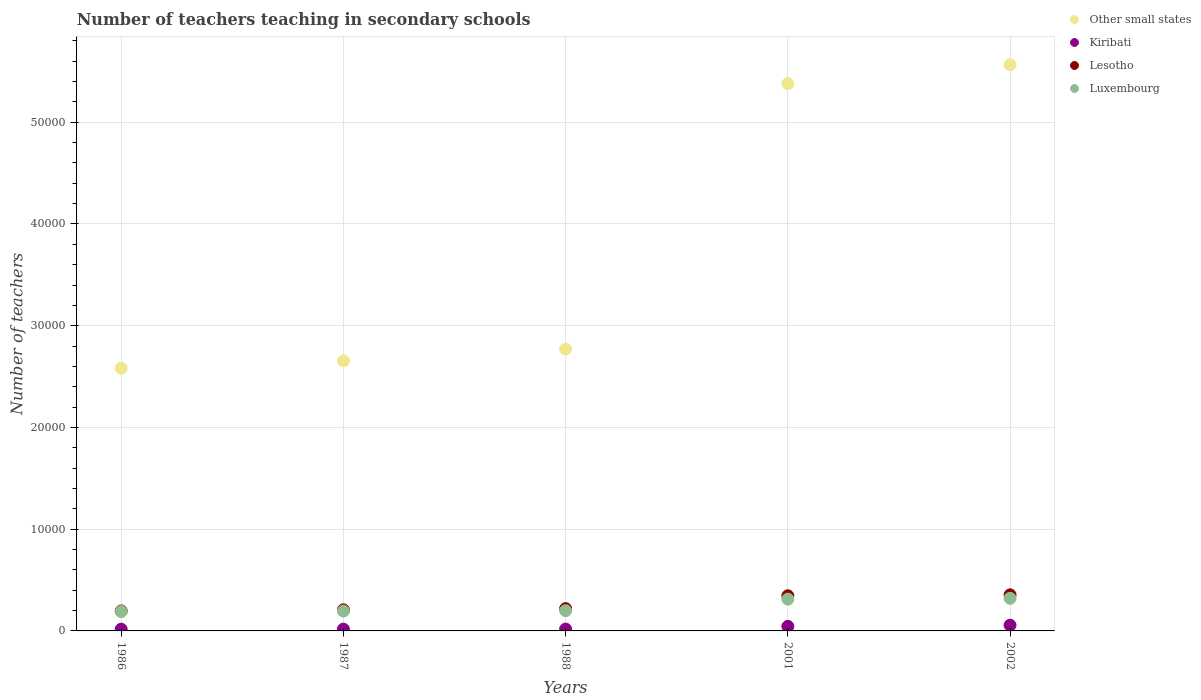How many different coloured dotlines are there?
Offer a very short reply. 4. Is the number of dotlines equal to the number of legend labels?
Offer a very short reply. Yes. What is the number of teachers teaching in secondary schools in Luxembourg in 2002?
Keep it short and to the point. 3206. Across all years, what is the maximum number of teachers teaching in secondary schools in Other small states?
Your answer should be very brief. 5.56e+04. Across all years, what is the minimum number of teachers teaching in secondary schools in Other small states?
Provide a succinct answer. 2.58e+04. In which year was the number of teachers teaching in secondary schools in Kiribati maximum?
Your response must be concise. 2002. In which year was the number of teachers teaching in secondary schools in Luxembourg minimum?
Your answer should be very brief. 1986. What is the total number of teachers teaching in secondary schools in Other small states in the graph?
Provide a short and direct response. 1.90e+05. What is the difference between the number of teachers teaching in secondary schools in Other small states in 1986 and that in 1987?
Your answer should be compact. -724.04. What is the difference between the number of teachers teaching in secondary schools in Other small states in 2002 and the number of teachers teaching in secondary schools in Lesotho in 1987?
Give a very brief answer. 5.36e+04. What is the average number of teachers teaching in secondary schools in Other small states per year?
Make the answer very short. 3.79e+04. In the year 1988, what is the difference between the number of teachers teaching in secondary schools in Lesotho and number of teachers teaching in secondary schools in Kiribati?
Keep it short and to the point. 2011. In how many years, is the number of teachers teaching in secondary schools in Kiribati greater than 50000?
Ensure brevity in your answer.  0. What is the ratio of the number of teachers teaching in secondary schools in Other small states in 1987 to that in 1988?
Your answer should be very brief. 0.96. Is the number of teachers teaching in secondary schools in Kiribati in 1986 less than that in 1987?
Keep it short and to the point. Yes. What is the difference between the highest and the second highest number of teachers teaching in secondary schools in Luxembourg?
Provide a short and direct response. 81. What is the difference between the highest and the lowest number of teachers teaching in secondary schools in Kiribati?
Offer a very short reply. 391. Is the sum of the number of teachers teaching in secondary schools in Kiribati in 1988 and 2002 greater than the maximum number of teachers teaching in secondary schools in Other small states across all years?
Your answer should be compact. No. Is it the case that in every year, the sum of the number of teachers teaching in secondary schools in Other small states and number of teachers teaching in secondary schools in Luxembourg  is greater than the number of teachers teaching in secondary schools in Lesotho?
Offer a terse response. Yes. Is the number of teachers teaching in secondary schools in Lesotho strictly less than the number of teachers teaching in secondary schools in Other small states over the years?
Give a very brief answer. Yes. Does the graph contain any zero values?
Your answer should be very brief. No. Does the graph contain grids?
Your answer should be compact. Yes. How are the legend labels stacked?
Give a very brief answer. Vertical. What is the title of the graph?
Your answer should be very brief. Number of teachers teaching in secondary schools. What is the label or title of the Y-axis?
Keep it short and to the point. Number of teachers. What is the Number of teachers of Other small states in 1986?
Provide a short and direct response. 2.58e+04. What is the Number of teachers in Kiribati in 1986?
Offer a very short reply. 171. What is the Number of teachers in Lesotho in 1986?
Your answer should be very brief. 1961. What is the Number of teachers of Luxembourg in 1986?
Provide a short and direct response. 1908. What is the Number of teachers in Other small states in 1987?
Ensure brevity in your answer.  2.65e+04. What is the Number of teachers of Kiribati in 1987?
Offer a terse response. 174. What is the Number of teachers of Lesotho in 1987?
Your answer should be compact. 2074. What is the Number of teachers of Luxembourg in 1987?
Your response must be concise. 1955. What is the Number of teachers in Other small states in 1988?
Provide a succinct answer. 2.77e+04. What is the Number of teachers of Kiribati in 1988?
Your response must be concise. 182. What is the Number of teachers in Lesotho in 1988?
Ensure brevity in your answer.  2193. What is the Number of teachers in Luxembourg in 1988?
Your answer should be very brief. 1990. What is the Number of teachers in Other small states in 2001?
Give a very brief answer. 5.38e+04. What is the Number of teachers of Kiribati in 2001?
Ensure brevity in your answer.  449. What is the Number of teachers of Lesotho in 2001?
Ensure brevity in your answer.  3455. What is the Number of teachers in Luxembourg in 2001?
Your response must be concise. 3125. What is the Number of teachers in Other small states in 2002?
Make the answer very short. 5.56e+04. What is the Number of teachers in Kiribati in 2002?
Your response must be concise. 562. What is the Number of teachers in Lesotho in 2002?
Your response must be concise. 3546. What is the Number of teachers in Luxembourg in 2002?
Your answer should be very brief. 3206. Across all years, what is the maximum Number of teachers of Other small states?
Your response must be concise. 5.56e+04. Across all years, what is the maximum Number of teachers in Kiribati?
Your response must be concise. 562. Across all years, what is the maximum Number of teachers in Lesotho?
Offer a very short reply. 3546. Across all years, what is the maximum Number of teachers in Luxembourg?
Keep it short and to the point. 3206. Across all years, what is the minimum Number of teachers in Other small states?
Give a very brief answer. 2.58e+04. Across all years, what is the minimum Number of teachers of Kiribati?
Ensure brevity in your answer.  171. Across all years, what is the minimum Number of teachers in Lesotho?
Keep it short and to the point. 1961. Across all years, what is the minimum Number of teachers of Luxembourg?
Offer a terse response. 1908. What is the total Number of teachers in Other small states in the graph?
Provide a short and direct response. 1.90e+05. What is the total Number of teachers in Kiribati in the graph?
Your answer should be compact. 1538. What is the total Number of teachers in Lesotho in the graph?
Your answer should be very brief. 1.32e+04. What is the total Number of teachers of Luxembourg in the graph?
Your answer should be very brief. 1.22e+04. What is the difference between the Number of teachers of Other small states in 1986 and that in 1987?
Provide a succinct answer. -724.04. What is the difference between the Number of teachers of Kiribati in 1986 and that in 1987?
Offer a very short reply. -3. What is the difference between the Number of teachers in Lesotho in 1986 and that in 1987?
Provide a succinct answer. -113. What is the difference between the Number of teachers in Luxembourg in 1986 and that in 1987?
Your answer should be compact. -47. What is the difference between the Number of teachers in Other small states in 1986 and that in 1988?
Ensure brevity in your answer.  -1891.17. What is the difference between the Number of teachers of Lesotho in 1986 and that in 1988?
Offer a terse response. -232. What is the difference between the Number of teachers of Luxembourg in 1986 and that in 1988?
Offer a very short reply. -82. What is the difference between the Number of teachers in Other small states in 1986 and that in 2001?
Offer a terse response. -2.80e+04. What is the difference between the Number of teachers in Kiribati in 1986 and that in 2001?
Keep it short and to the point. -278. What is the difference between the Number of teachers in Lesotho in 1986 and that in 2001?
Your response must be concise. -1494. What is the difference between the Number of teachers in Luxembourg in 1986 and that in 2001?
Offer a very short reply. -1217. What is the difference between the Number of teachers in Other small states in 1986 and that in 2002?
Give a very brief answer. -2.98e+04. What is the difference between the Number of teachers in Kiribati in 1986 and that in 2002?
Your answer should be compact. -391. What is the difference between the Number of teachers of Lesotho in 1986 and that in 2002?
Give a very brief answer. -1585. What is the difference between the Number of teachers of Luxembourg in 1986 and that in 2002?
Your answer should be very brief. -1298. What is the difference between the Number of teachers of Other small states in 1987 and that in 1988?
Provide a short and direct response. -1167.13. What is the difference between the Number of teachers in Lesotho in 1987 and that in 1988?
Offer a very short reply. -119. What is the difference between the Number of teachers in Luxembourg in 1987 and that in 1988?
Give a very brief answer. -35. What is the difference between the Number of teachers in Other small states in 1987 and that in 2001?
Offer a very short reply. -2.73e+04. What is the difference between the Number of teachers in Kiribati in 1987 and that in 2001?
Provide a succinct answer. -275. What is the difference between the Number of teachers in Lesotho in 1987 and that in 2001?
Make the answer very short. -1381. What is the difference between the Number of teachers of Luxembourg in 1987 and that in 2001?
Ensure brevity in your answer.  -1170. What is the difference between the Number of teachers in Other small states in 1987 and that in 2002?
Keep it short and to the point. -2.91e+04. What is the difference between the Number of teachers in Kiribati in 1987 and that in 2002?
Keep it short and to the point. -388. What is the difference between the Number of teachers of Lesotho in 1987 and that in 2002?
Make the answer very short. -1472. What is the difference between the Number of teachers in Luxembourg in 1987 and that in 2002?
Your response must be concise. -1251. What is the difference between the Number of teachers of Other small states in 1988 and that in 2001?
Your answer should be very brief. -2.61e+04. What is the difference between the Number of teachers of Kiribati in 1988 and that in 2001?
Your response must be concise. -267. What is the difference between the Number of teachers of Lesotho in 1988 and that in 2001?
Your answer should be compact. -1262. What is the difference between the Number of teachers in Luxembourg in 1988 and that in 2001?
Offer a terse response. -1135. What is the difference between the Number of teachers in Other small states in 1988 and that in 2002?
Give a very brief answer. -2.79e+04. What is the difference between the Number of teachers of Kiribati in 1988 and that in 2002?
Ensure brevity in your answer.  -380. What is the difference between the Number of teachers in Lesotho in 1988 and that in 2002?
Keep it short and to the point. -1353. What is the difference between the Number of teachers in Luxembourg in 1988 and that in 2002?
Your answer should be very brief. -1216. What is the difference between the Number of teachers in Other small states in 2001 and that in 2002?
Your answer should be compact. -1847.14. What is the difference between the Number of teachers of Kiribati in 2001 and that in 2002?
Provide a short and direct response. -113. What is the difference between the Number of teachers in Lesotho in 2001 and that in 2002?
Offer a terse response. -91. What is the difference between the Number of teachers of Luxembourg in 2001 and that in 2002?
Your answer should be very brief. -81. What is the difference between the Number of teachers in Other small states in 1986 and the Number of teachers in Kiribati in 1987?
Ensure brevity in your answer.  2.56e+04. What is the difference between the Number of teachers in Other small states in 1986 and the Number of teachers in Lesotho in 1987?
Provide a short and direct response. 2.37e+04. What is the difference between the Number of teachers of Other small states in 1986 and the Number of teachers of Luxembourg in 1987?
Ensure brevity in your answer.  2.39e+04. What is the difference between the Number of teachers of Kiribati in 1986 and the Number of teachers of Lesotho in 1987?
Make the answer very short. -1903. What is the difference between the Number of teachers of Kiribati in 1986 and the Number of teachers of Luxembourg in 1987?
Give a very brief answer. -1784. What is the difference between the Number of teachers in Other small states in 1986 and the Number of teachers in Kiribati in 1988?
Your answer should be compact. 2.56e+04. What is the difference between the Number of teachers of Other small states in 1986 and the Number of teachers of Lesotho in 1988?
Offer a terse response. 2.36e+04. What is the difference between the Number of teachers of Other small states in 1986 and the Number of teachers of Luxembourg in 1988?
Offer a terse response. 2.38e+04. What is the difference between the Number of teachers of Kiribati in 1986 and the Number of teachers of Lesotho in 1988?
Offer a very short reply. -2022. What is the difference between the Number of teachers in Kiribati in 1986 and the Number of teachers in Luxembourg in 1988?
Make the answer very short. -1819. What is the difference between the Number of teachers in Other small states in 1986 and the Number of teachers in Kiribati in 2001?
Offer a very short reply. 2.54e+04. What is the difference between the Number of teachers in Other small states in 1986 and the Number of teachers in Lesotho in 2001?
Keep it short and to the point. 2.24e+04. What is the difference between the Number of teachers of Other small states in 1986 and the Number of teachers of Luxembourg in 2001?
Keep it short and to the point. 2.27e+04. What is the difference between the Number of teachers in Kiribati in 1986 and the Number of teachers in Lesotho in 2001?
Your response must be concise. -3284. What is the difference between the Number of teachers of Kiribati in 1986 and the Number of teachers of Luxembourg in 2001?
Your answer should be very brief. -2954. What is the difference between the Number of teachers in Lesotho in 1986 and the Number of teachers in Luxembourg in 2001?
Provide a short and direct response. -1164. What is the difference between the Number of teachers in Other small states in 1986 and the Number of teachers in Kiribati in 2002?
Your answer should be compact. 2.53e+04. What is the difference between the Number of teachers of Other small states in 1986 and the Number of teachers of Lesotho in 2002?
Make the answer very short. 2.23e+04. What is the difference between the Number of teachers of Other small states in 1986 and the Number of teachers of Luxembourg in 2002?
Offer a terse response. 2.26e+04. What is the difference between the Number of teachers in Kiribati in 1986 and the Number of teachers in Lesotho in 2002?
Your answer should be very brief. -3375. What is the difference between the Number of teachers in Kiribati in 1986 and the Number of teachers in Luxembourg in 2002?
Offer a terse response. -3035. What is the difference between the Number of teachers of Lesotho in 1986 and the Number of teachers of Luxembourg in 2002?
Make the answer very short. -1245. What is the difference between the Number of teachers in Other small states in 1987 and the Number of teachers in Kiribati in 1988?
Offer a terse response. 2.64e+04. What is the difference between the Number of teachers in Other small states in 1987 and the Number of teachers in Lesotho in 1988?
Ensure brevity in your answer.  2.43e+04. What is the difference between the Number of teachers of Other small states in 1987 and the Number of teachers of Luxembourg in 1988?
Provide a short and direct response. 2.46e+04. What is the difference between the Number of teachers in Kiribati in 1987 and the Number of teachers in Lesotho in 1988?
Ensure brevity in your answer.  -2019. What is the difference between the Number of teachers of Kiribati in 1987 and the Number of teachers of Luxembourg in 1988?
Provide a short and direct response. -1816. What is the difference between the Number of teachers in Other small states in 1987 and the Number of teachers in Kiribati in 2001?
Your answer should be very brief. 2.61e+04. What is the difference between the Number of teachers in Other small states in 1987 and the Number of teachers in Lesotho in 2001?
Give a very brief answer. 2.31e+04. What is the difference between the Number of teachers in Other small states in 1987 and the Number of teachers in Luxembourg in 2001?
Your response must be concise. 2.34e+04. What is the difference between the Number of teachers in Kiribati in 1987 and the Number of teachers in Lesotho in 2001?
Offer a very short reply. -3281. What is the difference between the Number of teachers in Kiribati in 1987 and the Number of teachers in Luxembourg in 2001?
Ensure brevity in your answer.  -2951. What is the difference between the Number of teachers of Lesotho in 1987 and the Number of teachers of Luxembourg in 2001?
Your answer should be very brief. -1051. What is the difference between the Number of teachers of Other small states in 1987 and the Number of teachers of Kiribati in 2002?
Offer a terse response. 2.60e+04. What is the difference between the Number of teachers of Other small states in 1987 and the Number of teachers of Lesotho in 2002?
Keep it short and to the point. 2.30e+04. What is the difference between the Number of teachers in Other small states in 1987 and the Number of teachers in Luxembourg in 2002?
Provide a succinct answer. 2.33e+04. What is the difference between the Number of teachers of Kiribati in 1987 and the Number of teachers of Lesotho in 2002?
Give a very brief answer. -3372. What is the difference between the Number of teachers in Kiribati in 1987 and the Number of teachers in Luxembourg in 2002?
Provide a succinct answer. -3032. What is the difference between the Number of teachers of Lesotho in 1987 and the Number of teachers of Luxembourg in 2002?
Offer a very short reply. -1132. What is the difference between the Number of teachers in Other small states in 1988 and the Number of teachers in Kiribati in 2001?
Keep it short and to the point. 2.73e+04. What is the difference between the Number of teachers of Other small states in 1988 and the Number of teachers of Lesotho in 2001?
Provide a short and direct response. 2.43e+04. What is the difference between the Number of teachers of Other small states in 1988 and the Number of teachers of Luxembourg in 2001?
Keep it short and to the point. 2.46e+04. What is the difference between the Number of teachers of Kiribati in 1988 and the Number of teachers of Lesotho in 2001?
Ensure brevity in your answer.  -3273. What is the difference between the Number of teachers of Kiribati in 1988 and the Number of teachers of Luxembourg in 2001?
Give a very brief answer. -2943. What is the difference between the Number of teachers in Lesotho in 1988 and the Number of teachers in Luxembourg in 2001?
Your response must be concise. -932. What is the difference between the Number of teachers in Other small states in 1988 and the Number of teachers in Kiribati in 2002?
Give a very brief answer. 2.71e+04. What is the difference between the Number of teachers of Other small states in 1988 and the Number of teachers of Lesotho in 2002?
Offer a terse response. 2.42e+04. What is the difference between the Number of teachers in Other small states in 1988 and the Number of teachers in Luxembourg in 2002?
Keep it short and to the point. 2.45e+04. What is the difference between the Number of teachers in Kiribati in 1988 and the Number of teachers in Lesotho in 2002?
Keep it short and to the point. -3364. What is the difference between the Number of teachers of Kiribati in 1988 and the Number of teachers of Luxembourg in 2002?
Provide a short and direct response. -3024. What is the difference between the Number of teachers in Lesotho in 1988 and the Number of teachers in Luxembourg in 2002?
Keep it short and to the point. -1013. What is the difference between the Number of teachers of Other small states in 2001 and the Number of teachers of Kiribati in 2002?
Your answer should be very brief. 5.32e+04. What is the difference between the Number of teachers of Other small states in 2001 and the Number of teachers of Lesotho in 2002?
Make the answer very short. 5.03e+04. What is the difference between the Number of teachers in Other small states in 2001 and the Number of teachers in Luxembourg in 2002?
Give a very brief answer. 5.06e+04. What is the difference between the Number of teachers in Kiribati in 2001 and the Number of teachers in Lesotho in 2002?
Ensure brevity in your answer.  -3097. What is the difference between the Number of teachers in Kiribati in 2001 and the Number of teachers in Luxembourg in 2002?
Your answer should be very brief. -2757. What is the difference between the Number of teachers of Lesotho in 2001 and the Number of teachers of Luxembourg in 2002?
Your answer should be very brief. 249. What is the average Number of teachers in Other small states per year?
Provide a short and direct response. 3.79e+04. What is the average Number of teachers of Kiribati per year?
Your response must be concise. 307.6. What is the average Number of teachers of Lesotho per year?
Keep it short and to the point. 2645.8. What is the average Number of teachers of Luxembourg per year?
Your response must be concise. 2436.8. In the year 1986, what is the difference between the Number of teachers in Other small states and Number of teachers in Kiribati?
Provide a succinct answer. 2.56e+04. In the year 1986, what is the difference between the Number of teachers in Other small states and Number of teachers in Lesotho?
Offer a very short reply. 2.39e+04. In the year 1986, what is the difference between the Number of teachers of Other small states and Number of teachers of Luxembourg?
Offer a very short reply. 2.39e+04. In the year 1986, what is the difference between the Number of teachers of Kiribati and Number of teachers of Lesotho?
Give a very brief answer. -1790. In the year 1986, what is the difference between the Number of teachers in Kiribati and Number of teachers in Luxembourg?
Offer a terse response. -1737. In the year 1986, what is the difference between the Number of teachers of Lesotho and Number of teachers of Luxembourg?
Offer a terse response. 53. In the year 1987, what is the difference between the Number of teachers of Other small states and Number of teachers of Kiribati?
Make the answer very short. 2.64e+04. In the year 1987, what is the difference between the Number of teachers of Other small states and Number of teachers of Lesotho?
Provide a succinct answer. 2.45e+04. In the year 1987, what is the difference between the Number of teachers in Other small states and Number of teachers in Luxembourg?
Your answer should be compact. 2.46e+04. In the year 1987, what is the difference between the Number of teachers in Kiribati and Number of teachers in Lesotho?
Give a very brief answer. -1900. In the year 1987, what is the difference between the Number of teachers in Kiribati and Number of teachers in Luxembourg?
Offer a terse response. -1781. In the year 1987, what is the difference between the Number of teachers in Lesotho and Number of teachers in Luxembourg?
Offer a very short reply. 119. In the year 1988, what is the difference between the Number of teachers in Other small states and Number of teachers in Kiribati?
Your response must be concise. 2.75e+04. In the year 1988, what is the difference between the Number of teachers in Other small states and Number of teachers in Lesotho?
Give a very brief answer. 2.55e+04. In the year 1988, what is the difference between the Number of teachers in Other small states and Number of teachers in Luxembourg?
Your answer should be compact. 2.57e+04. In the year 1988, what is the difference between the Number of teachers in Kiribati and Number of teachers in Lesotho?
Offer a terse response. -2011. In the year 1988, what is the difference between the Number of teachers in Kiribati and Number of teachers in Luxembourg?
Your response must be concise. -1808. In the year 1988, what is the difference between the Number of teachers in Lesotho and Number of teachers in Luxembourg?
Provide a succinct answer. 203. In the year 2001, what is the difference between the Number of teachers of Other small states and Number of teachers of Kiribati?
Make the answer very short. 5.33e+04. In the year 2001, what is the difference between the Number of teachers in Other small states and Number of teachers in Lesotho?
Provide a short and direct response. 5.03e+04. In the year 2001, what is the difference between the Number of teachers of Other small states and Number of teachers of Luxembourg?
Your answer should be very brief. 5.07e+04. In the year 2001, what is the difference between the Number of teachers in Kiribati and Number of teachers in Lesotho?
Your answer should be compact. -3006. In the year 2001, what is the difference between the Number of teachers in Kiribati and Number of teachers in Luxembourg?
Provide a short and direct response. -2676. In the year 2001, what is the difference between the Number of teachers of Lesotho and Number of teachers of Luxembourg?
Ensure brevity in your answer.  330. In the year 2002, what is the difference between the Number of teachers in Other small states and Number of teachers in Kiribati?
Provide a succinct answer. 5.51e+04. In the year 2002, what is the difference between the Number of teachers of Other small states and Number of teachers of Lesotho?
Make the answer very short. 5.21e+04. In the year 2002, what is the difference between the Number of teachers of Other small states and Number of teachers of Luxembourg?
Ensure brevity in your answer.  5.24e+04. In the year 2002, what is the difference between the Number of teachers in Kiribati and Number of teachers in Lesotho?
Make the answer very short. -2984. In the year 2002, what is the difference between the Number of teachers in Kiribati and Number of teachers in Luxembourg?
Provide a short and direct response. -2644. In the year 2002, what is the difference between the Number of teachers of Lesotho and Number of teachers of Luxembourg?
Give a very brief answer. 340. What is the ratio of the Number of teachers of Other small states in 1986 to that in 1987?
Keep it short and to the point. 0.97. What is the ratio of the Number of teachers of Kiribati in 1986 to that in 1987?
Give a very brief answer. 0.98. What is the ratio of the Number of teachers in Lesotho in 1986 to that in 1987?
Your answer should be very brief. 0.95. What is the ratio of the Number of teachers of Other small states in 1986 to that in 1988?
Offer a terse response. 0.93. What is the ratio of the Number of teachers in Kiribati in 1986 to that in 1988?
Ensure brevity in your answer.  0.94. What is the ratio of the Number of teachers of Lesotho in 1986 to that in 1988?
Keep it short and to the point. 0.89. What is the ratio of the Number of teachers in Luxembourg in 1986 to that in 1988?
Give a very brief answer. 0.96. What is the ratio of the Number of teachers in Other small states in 1986 to that in 2001?
Your response must be concise. 0.48. What is the ratio of the Number of teachers of Kiribati in 1986 to that in 2001?
Your answer should be compact. 0.38. What is the ratio of the Number of teachers in Lesotho in 1986 to that in 2001?
Give a very brief answer. 0.57. What is the ratio of the Number of teachers in Luxembourg in 1986 to that in 2001?
Provide a short and direct response. 0.61. What is the ratio of the Number of teachers of Other small states in 1986 to that in 2002?
Provide a succinct answer. 0.46. What is the ratio of the Number of teachers of Kiribati in 1986 to that in 2002?
Your answer should be compact. 0.3. What is the ratio of the Number of teachers in Lesotho in 1986 to that in 2002?
Provide a succinct answer. 0.55. What is the ratio of the Number of teachers of Luxembourg in 1986 to that in 2002?
Give a very brief answer. 0.6. What is the ratio of the Number of teachers in Other small states in 1987 to that in 1988?
Make the answer very short. 0.96. What is the ratio of the Number of teachers in Kiribati in 1987 to that in 1988?
Keep it short and to the point. 0.96. What is the ratio of the Number of teachers in Lesotho in 1987 to that in 1988?
Give a very brief answer. 0.95. What is the ratio of the Number of teachers of Luxembourg in 1987 to that in 1988?
Your response must be concise. 0.98. What is the ratio of the Number of teachers in Other small states in 1987 to that in 2001?
Give a very brief answer. 0.49. What is the ratio of the Number of teachers in Kiribati in 1987 to that in 2001?
Offer a terse response. 0.39. What is the ratio of the Number of teachers in Lesotho in 1987 to that in 2001?
Offer a terse response. 0.6. What is the ratio of the Number of teachers of Luxembourg in 1987 to that in 2001?
Your response must be concise. 0.63. What is the ratio of the Number of teachers of Other small states in 1987 to that in 2002?
Offer a very short reply. 0.48. What is the ratio of the Number of teachers of Kiribati in 1987 to that in 2002?
Give a very brief answer. 0.31. What is the ratio of the Number of teachers of Lesotho in 1987 to that in 2002?
Make the answer very short. 0.58. What is the ratio of the Number of teachers of Luxembourg in 1987 to that in 2002?
Make the answer very short. 0.61. What is the ratio of the Number of teachers of Other small states in 1988 to that in 2001?
Offer a very short reply. 0.52. What is the ratio of the Number of teachers in Kiribati in 1988 to that in 2001?
Your answer should be compact. 0.41. What is the ratio of the Number of teachers in Lesotho in 1988 to that in 2001?
Give a very brief answer. 0.63. What is the ratio of the Number of teachers of Luxembourg in 1988 to that in 2001?
Keep it short and to the point. 0.64. What is the ratio of the Number of teachers of Other small states in 1988 to that in 2002?
Keep it short and to the point. 0.5. What is the ratio of the Number of teachers of Kiribati in 1988 to that in 2002?
Give a very brief answer. 0.32. What is the ratio of the Number of teachers of Lesotho in 1988 to that in 2002?
Make the answer very short. 0.62. What is the ratio of the Number of teachers of Luxembourg in 1988 to that in 2002?
Offer a very short reply. 0.62. What is the ratio of the Number of teachers of Other small states in 2001 to that in 2002?
Make the answer very short. 0.97. What is the ratio of the Number of teachers in Kiribati in 2001 to that in 2002?
Give a very brief answer. 0.8. What is the ratio of the Number of teachers of Lesotho in 2001 to that in 2002?
Ensure brevity in your answer.  0.97. What is the ratio of the Number of teachers of Luxembourg in 2001 to that in 2002?
Your response must be concise. 0.97. What is the difference between the highest and the second highest Number of teachers of Other small states?
Ensure brevity in your answer.  1847.14. What is the difference between the highest and the second highest Number of teachers of Kiribati?
Your response must be concise. 113. What is the difference between the highest and the second highest Number of teachers of Lesotho?
Ensure brevity in your answer.  91. What is the difference between the highest and the lowest Number of teachers in Other small states?
Offer a very short reply. 2.98e+04. What is the difference between the highest and the lowest Number of teachers of Kiribati?
Offer a very short reply. 391. What is the difference between the highest and the lowest Number of teachers in Lesotho?
Give a very brief answer. 1585. What is the difference between the highest and the lowest Number of teachers of Luxembourg?
Offer a terse response. 1298. 